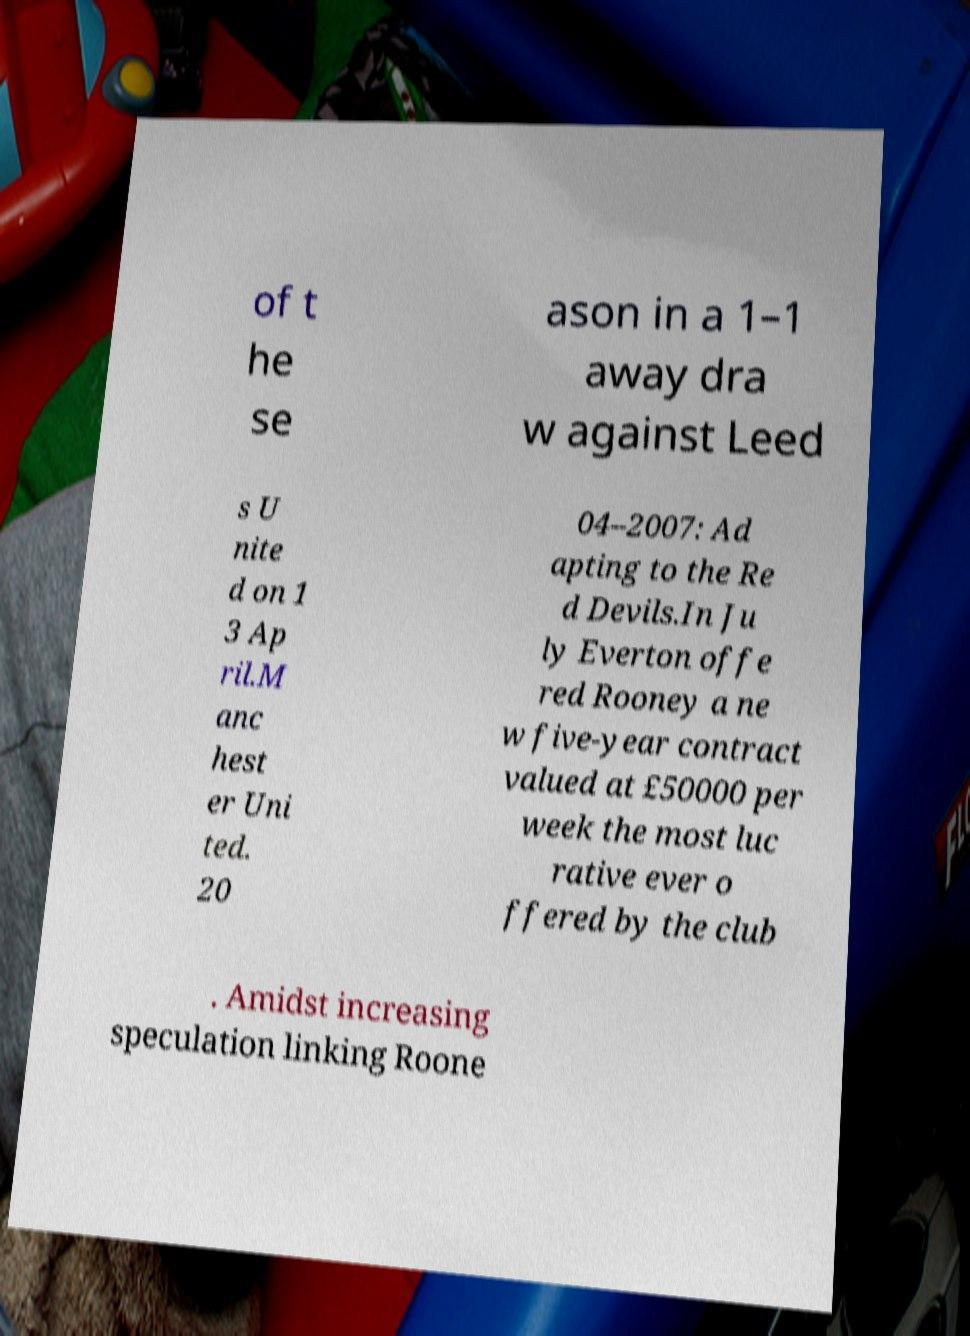There's text embedded in this image that I need extracted. Can you transcribe it verbatim? of t he se ason in a 1–1 away dra w against Leed s U nite d on 1 3 Ap ril.M anc hest er Uni ted. 20 04–2007: Ad apting to the Re d Devils.In Ju ly Everton offe red Rooney a ne w five-year contract valued at £50000 per week the most luc rative ever o ffered by the club . Amidst increasing speculation linking Roone 